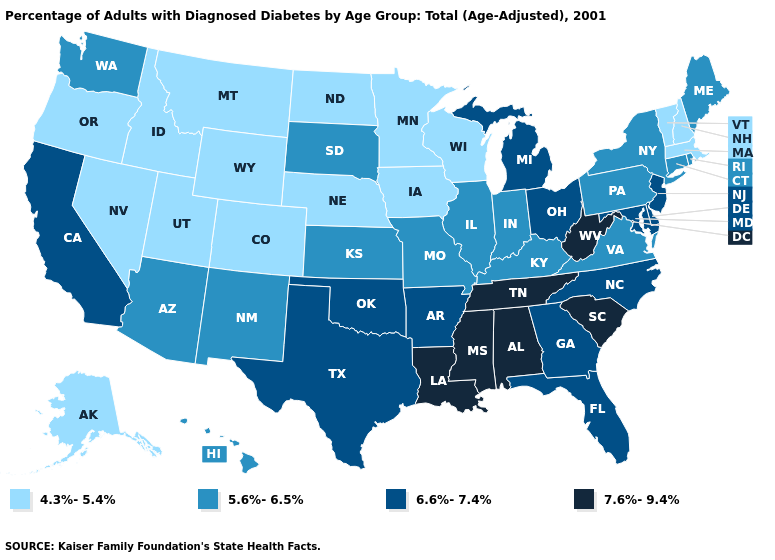Which states have the lowest value in the Northeast?
Keep it brief. Massachusetts, New Hampshire, Vermont. Does Massachusetts have the lowest value in the USA?
Give a very brief answer. Yes. Which states hav the highest value in the South?
Keep it brief. Alabama, Louisiana, Mississippi, South Carolina, Tennessee, West Virginia. What is the value of Kansas?
Give a very brief answer. 5.6%-6.5%. What is the value of Utah?
Quick response, please. 4.3%-5.4%. Name the states that have a value in the range 6.6%-7.4%?
Concise answer only. Arkansas, California, Delaware, Florida, Georgia, Maryland, Michigan, New Jersey, North Carolina, Ohio, Oklahoma, Texas. What is the value of Pennsylvania?
Quick response, please. 5.6%-6.5%. What is the highest value in the South ?
Answer briefly. 7.6%-9.4%. Name the states that have a value in the range 4.3%-5.4%?
Give a very brief answer. Alaska, Colorado, Idaho, Iowa, Massachusetts, Minnesota, Montana, Nebraska, Nevada, New Hampshire, North Dakota, Oregon, Utah, Vermont, Wisconsin, Wyoming. What is the value of Texas?
Concise answer only. 6.6%-7.4%. What is the lowest value in the South?
Keep it brief. 5.6%-6.5%. Does the map have missing data?
Write a very short answer. No. What is the highest value in states that border Wyoming?
Answer briefly. 5.6%-6.5%. Does Montana have a higher value than Rhode Island?
Write a very short answer. No. What is the value of Maryland?
Short answer required. 6.6%-7.4%. 